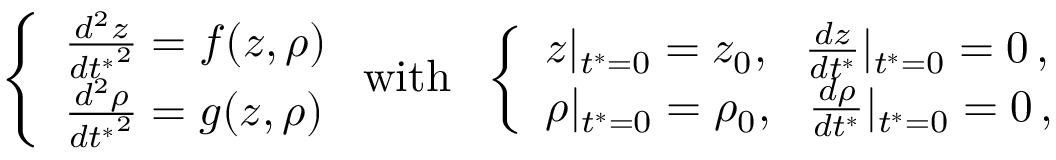Convert formula to latex. <formula><loc_0><loc_0><loc_500><loc_500>\left \{ \begin{array} { l l } { \frac { d ^ { 2 } z } { { d t ^ { * } } ^ { 2 } } = f ( z , \rho ) } \\ { \frac { d ^ { 2 } \rho } { { d t ^ { * } } ^ { 2 } } = g ( z , \rho ) } \end{array} w i t h \quad l e f t \{ \begin{array} { l l } { z | _ { t ^ { * } = 0 } = z _ { 0 } , \quad f r a c { d z } { d t ^ { * } } | _ { t ^ { * } = 0 } = 0 \, , } \\ { \rho | _ { t ^ { * } = 0 } = \rho _ { 0 } , \quad f r a c { d \rho } { d t ^ { * } } | _ { t ^ { * } = 0 } = 0 \, , } \end{array}</formula> 